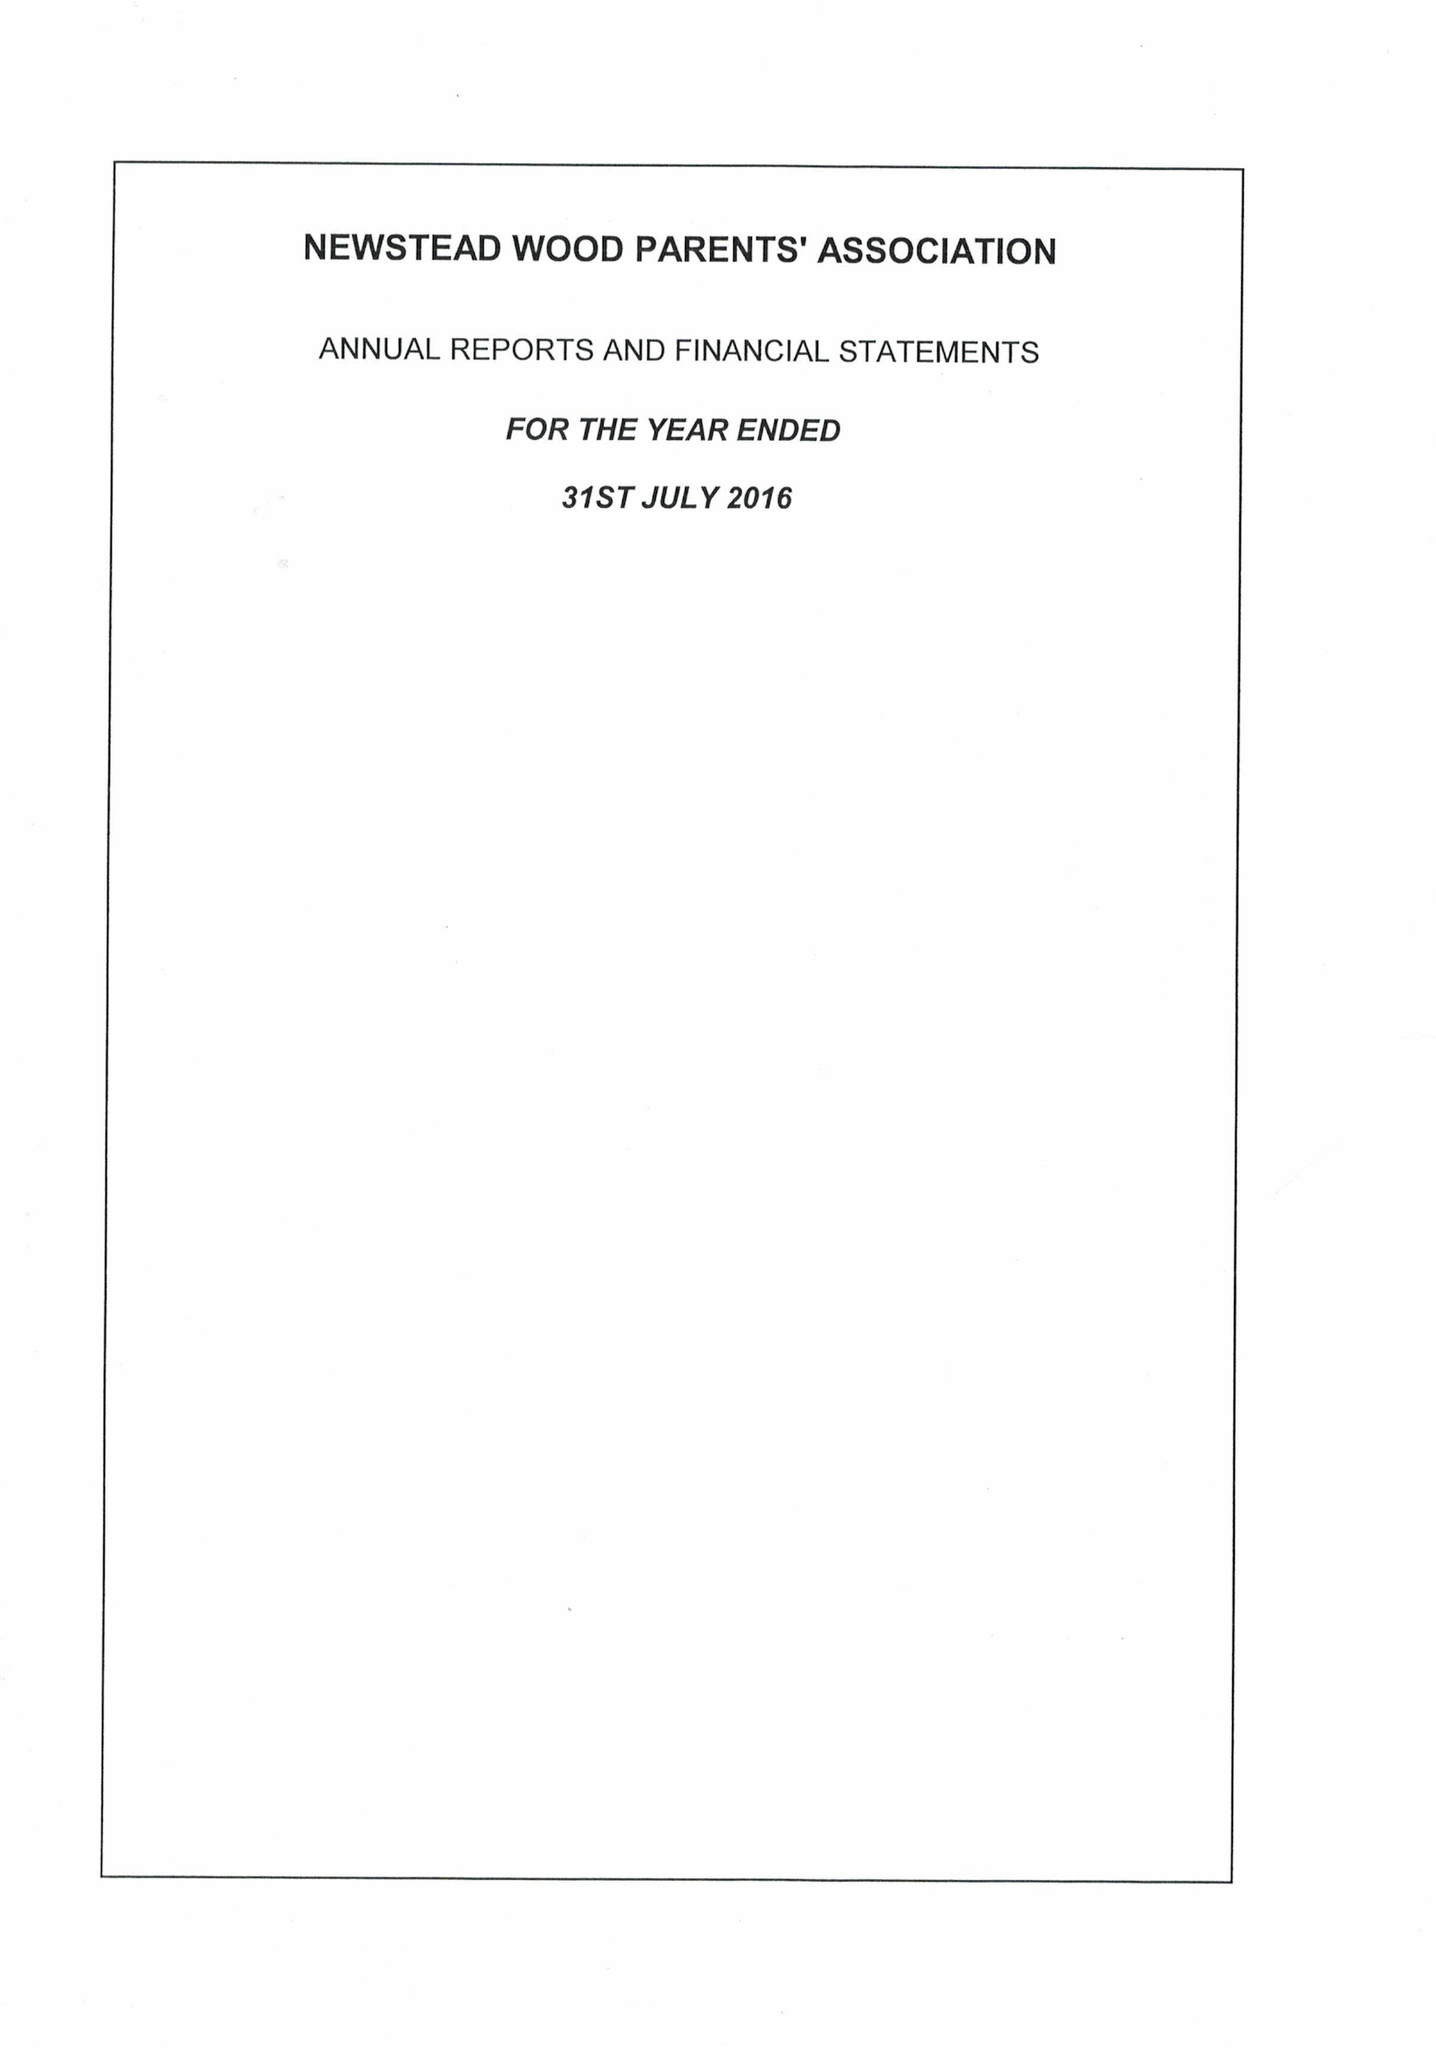What is the value for the address__street_line?
Answer the question using a single word or phrase. PORRINGTON CLOSE 